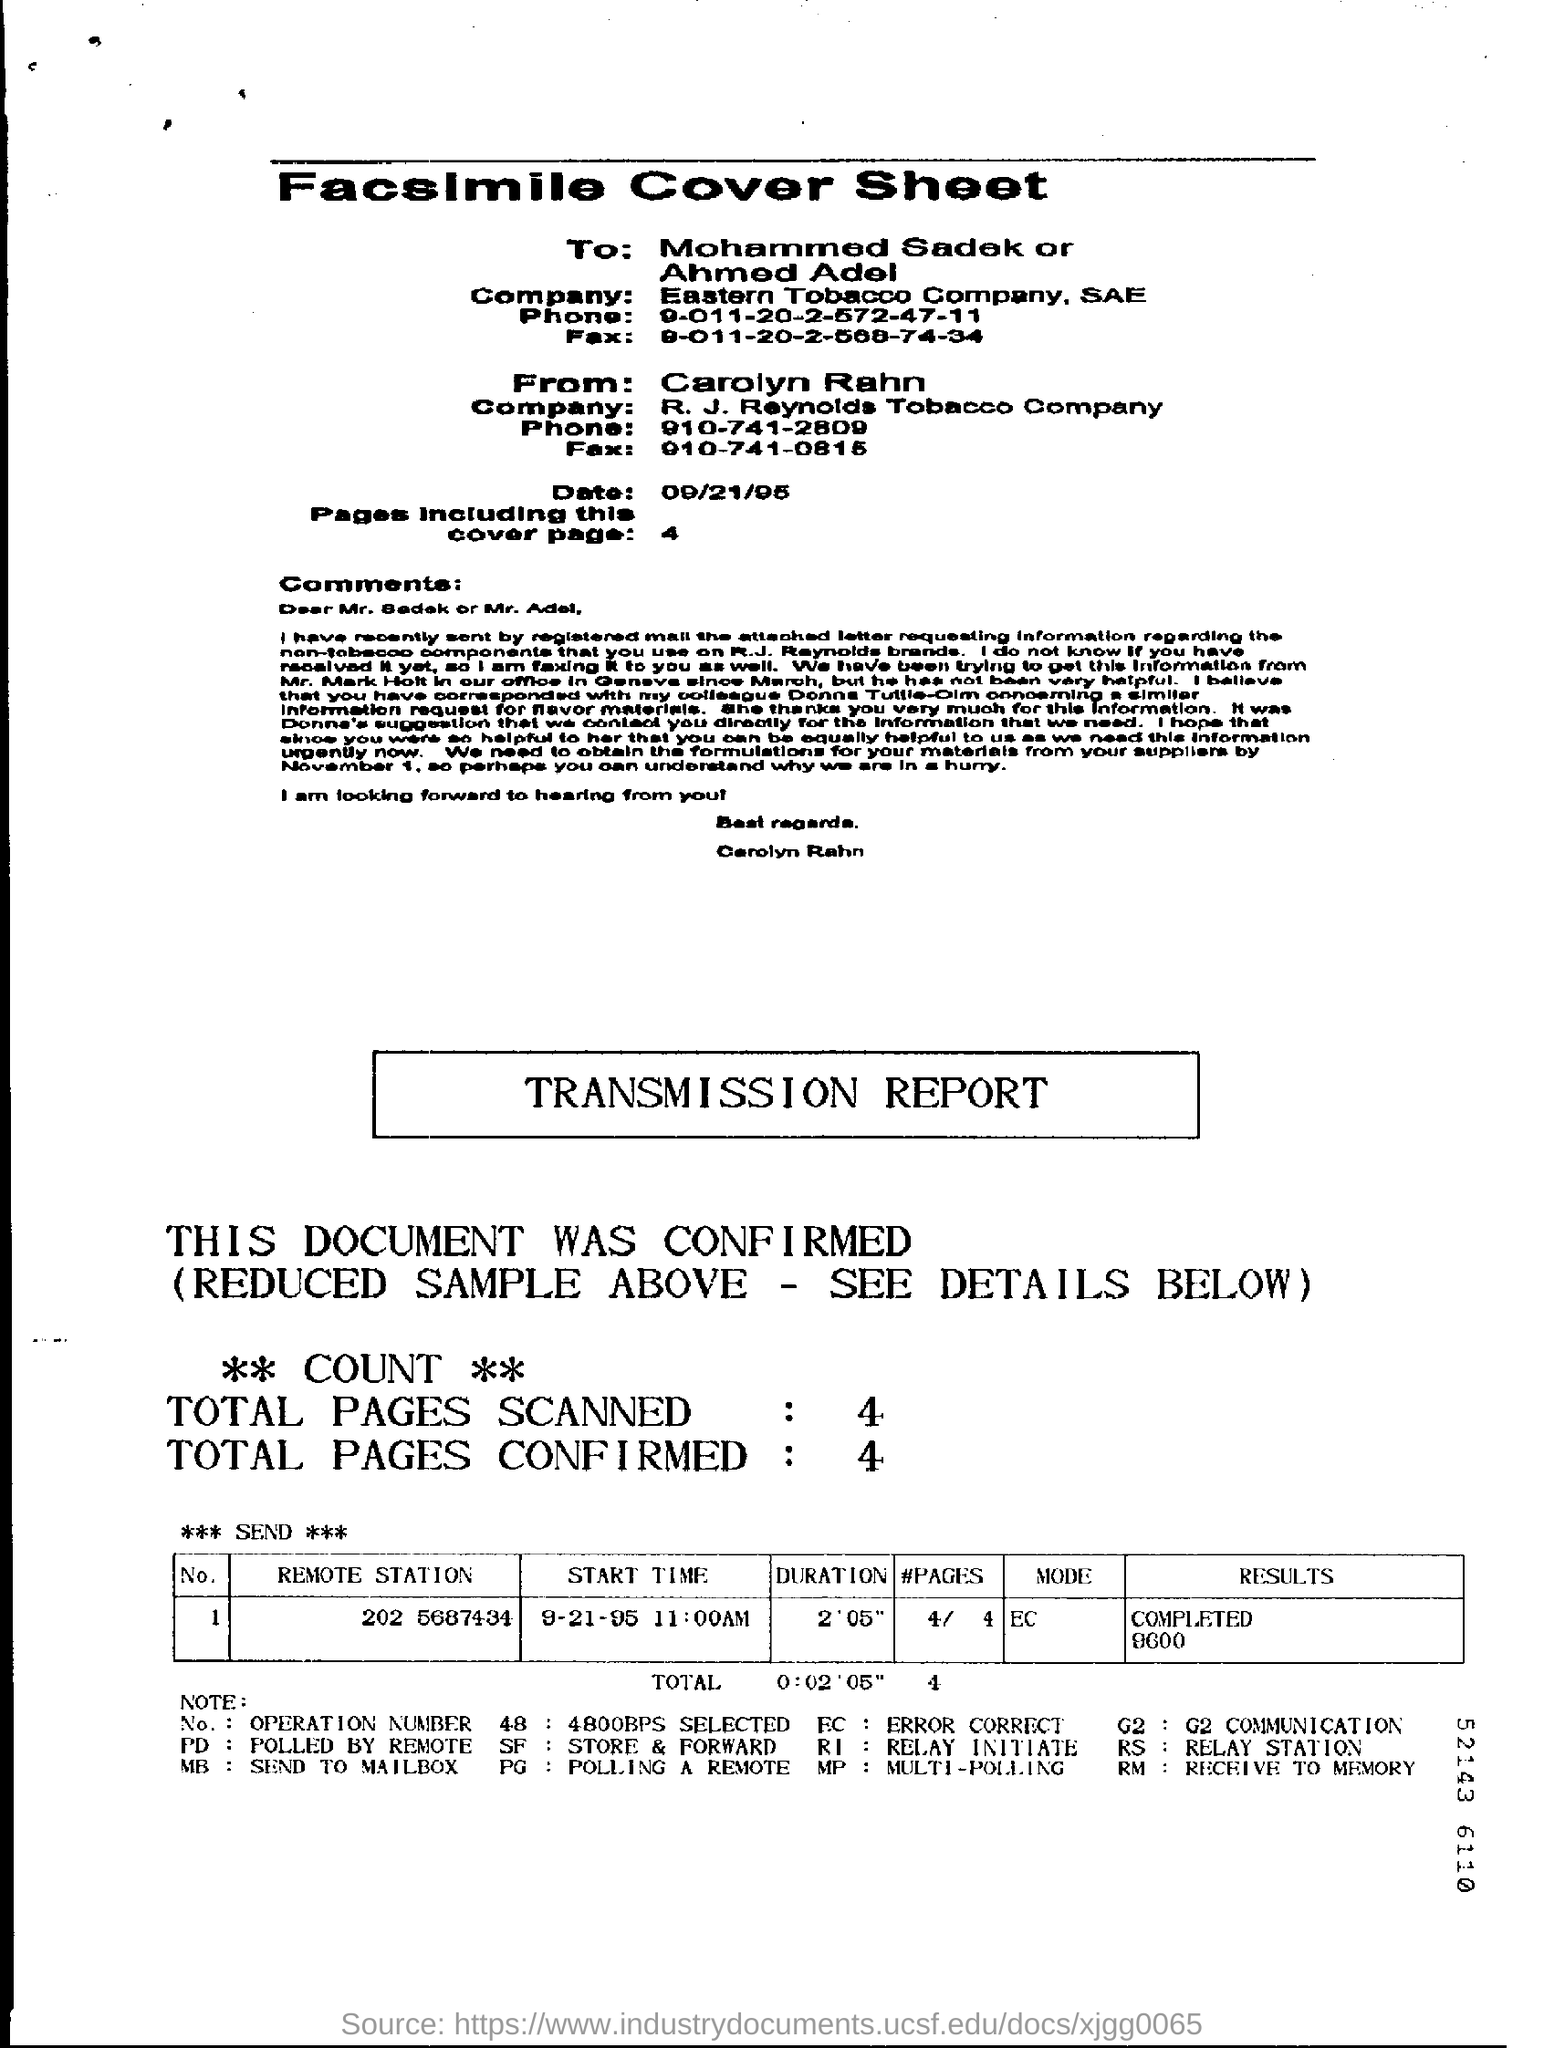Draw attention to some important aspects in this diagram. The facsimile cover sheet is dated September 21, 1995. There are 4 pages mentioned in the sheet. There are a total of 4 confirmed pages. The total number of pages scanned is 4. 